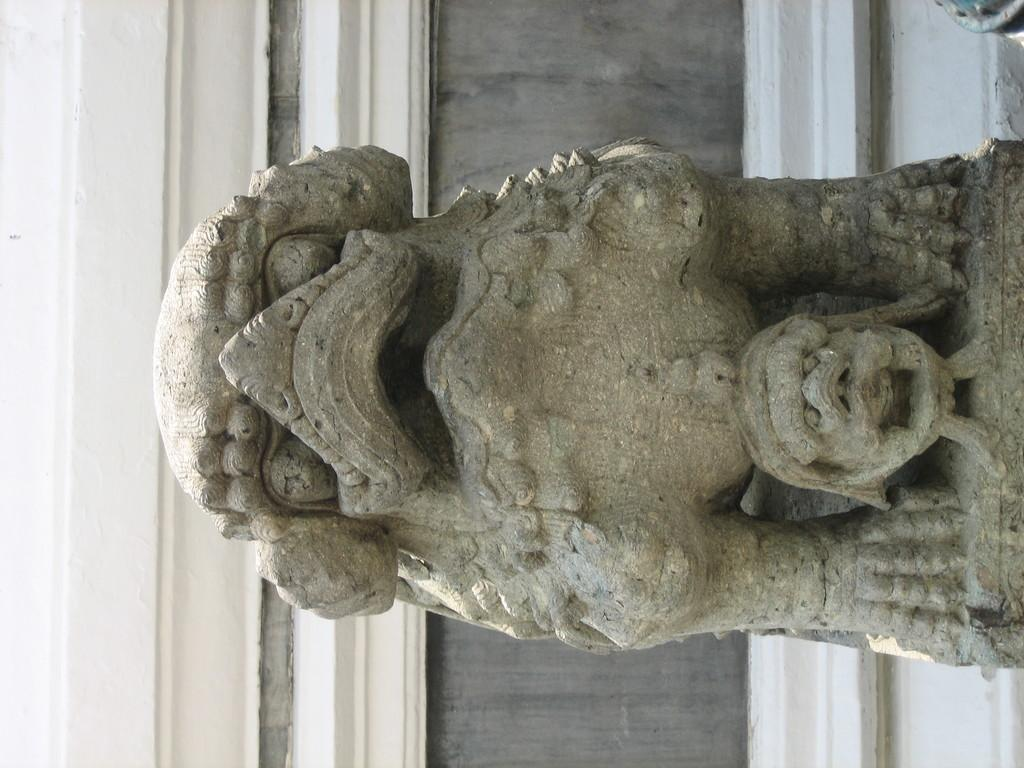What is the main subject of the image? The main subject of the image is a sculptor. What can be seen in the background of the image? There is a wall in the background of the image. Can you describe the object that appears to be truncated towards the top of the image? Unfortunately, the facts provided do not give enough information to describe the truncated object in detail. How many gloves can be seen on the sculptor's hands in the image? There are no gloves visible on the sculptor's hands in the image. What color are the eyes of the scarecrow in the image? There is no scarecrow present in the image. 